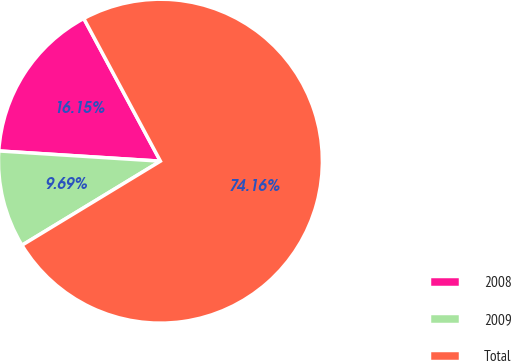<chart> <loc_0><loc_0><loc_500><loc_500><pie_chart><fcel>2008<fcel>2009<fcel>Total<nl><fcel>16.15%<fcel>9.69%<fcel>74.16%<nl></chart> 